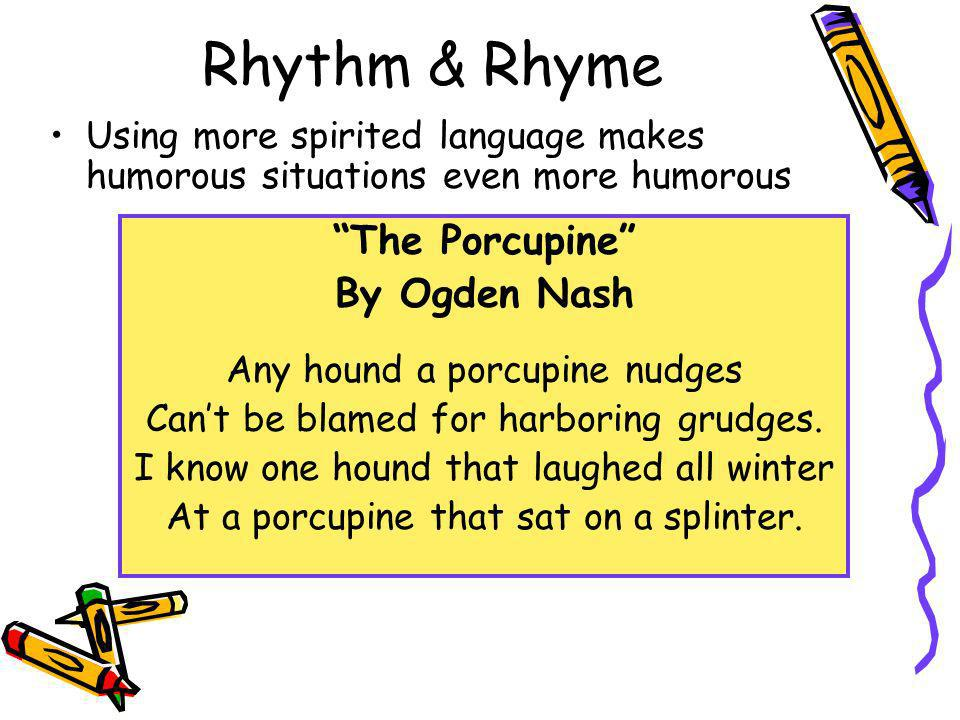What poetic technique does Ogden Nash utilize in the featured poem to create humor? Ogden Nash employs a distinctive blend of rhyme and absurd situational humor in the poem. He uses the rhyme scheme to connect words like 'nudges' and 'grudges,' as well as 'winter' and 'splinter,' which not only establishes a rhythm but also enhances the whimsical tone of the verse. This choice of rhyming pairs combined with the ridiculous image of a porcupine sitting on a splinter contributes to the lighthearted feel of the work. The playful language and the surprising conclusion where the discomfort is experienced by the porcupine, rather than the hound, further embellish the humorous effect. Nash’s clever manipulation of simple narrative and language tricks entices readers into a light, amusing reflection on nature and conflict. 